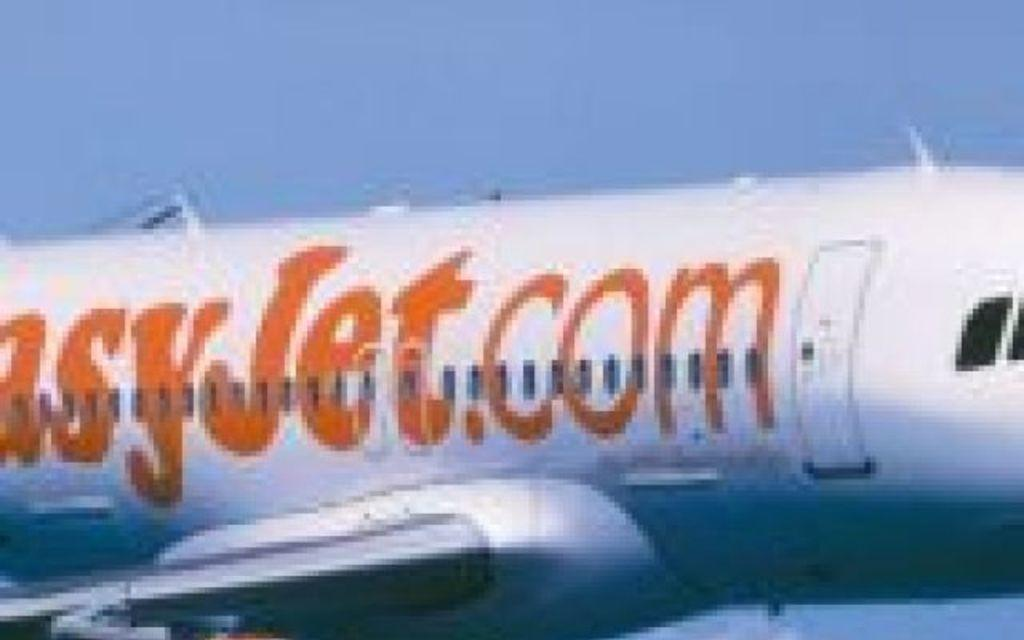What is the main subject of the image? The main subject of the image is an airplane. What features can be seen on the airplane? The airplane has windows. What else is visible in the image besides the airplane? The sky is visible in the image. What type of sock is hanging from the airplane in the image? There is no sock hanging from the airplane in the image. Can you describe the face of the pilot in the image? There is no pilot or face visible in the image; it only features an airplane and the sky. 